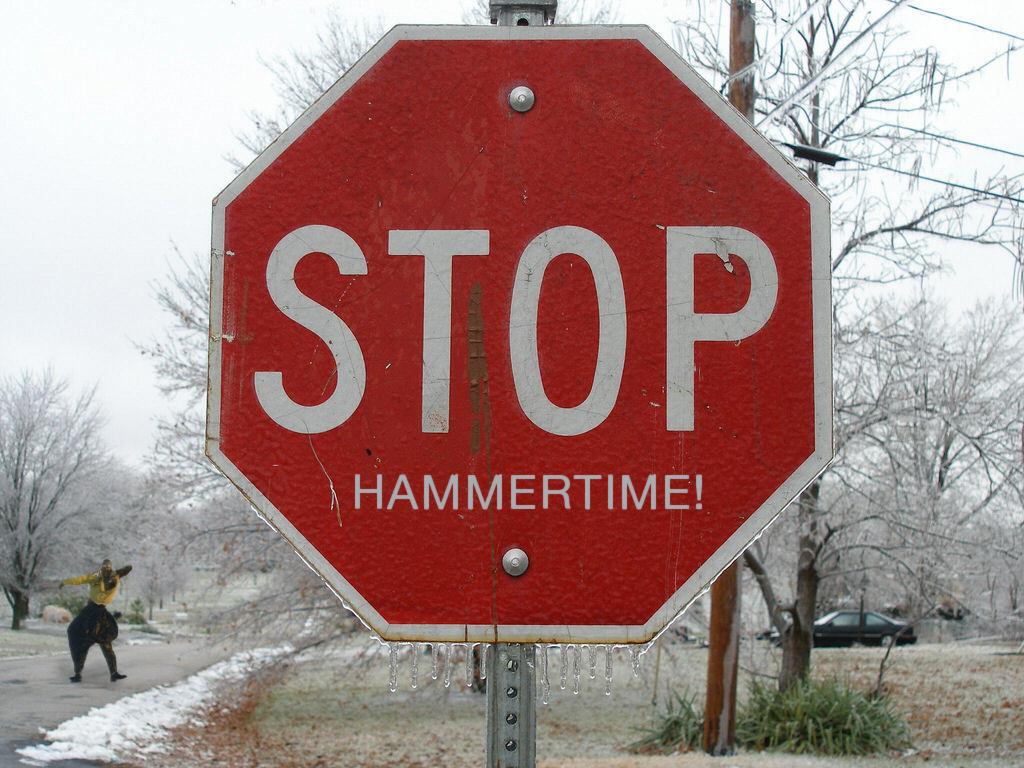What kind of sign is this?
Provide a short and direct response. Stop. What does it say below the word stop?
Your response must be concise. Hammertime!. 